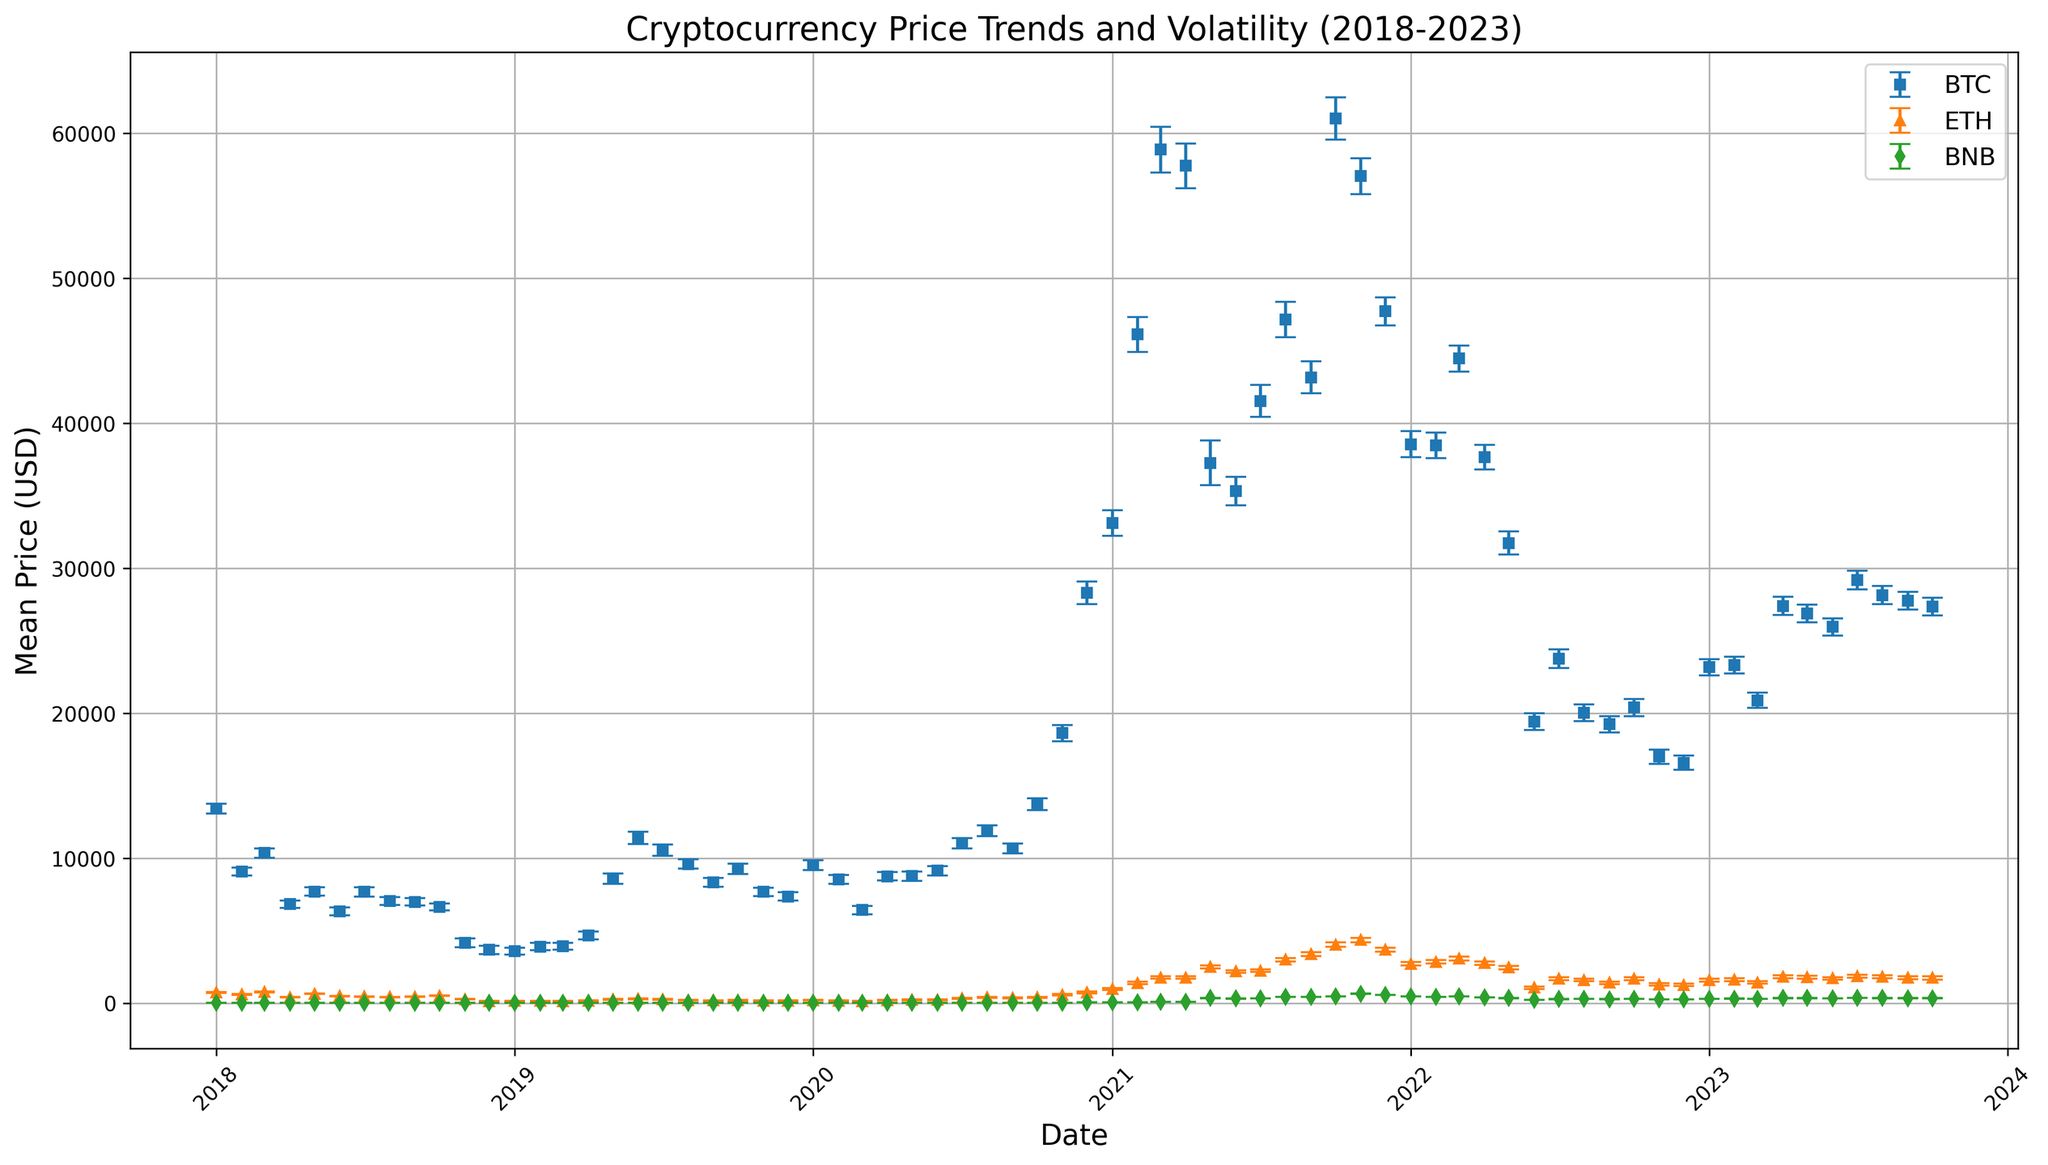What is the range of BTC mean prices during the given period? To determine the range of BTC mean prices, subtract the lowest mean price from the highest mean price. From the chart, the lowest BTC mean price is around December 2018 at approximately $3669.97, and the highest mean price is around March 2021 at approximately $58874.45. Hence, the range is $58874.45 - $3669.97.
Answer: $55204.48 Which cryptocurrency showed the highest price volatility in May 2021? Price volatility can be inferred from the standard deviation. In May 2021, compare the error bars (std deviation) of BTC, ETH, and BNB. BTC's error bar looks around 1542.12, ETH's around 96.78, and BNB's around 6.12. BTC clearly shows the highest price volatility.
Answer: BTC How did ETH's mean price change from January 2018 to February 2018? We need to compare ETH's mean prices between these two months. In January 2018, the mean price of ETH is approximately $728.45. In February 2018, it's about $598.32. Calculate the change as $728.45 - $598.32.
Answer: Decreased by $130.13 Between July 2020 and December 2020, did any cryptocurrency show a period of decreasing mean prices? Check the mean price trends for BTC, ETH, and BNB between these months. BTC shows an increasing trend during this period, ETH also increases, and BNB shows a slight decrease, especially August 2020 to September 2020.
Answer: Yes, BNB Which month recorded the highest discrepancy between BTC and ETH's mean prices? To answer this, compute the differences between BTC and ETH's mean prices each month. Compare the absolute values of these differences to identify the largest one. From a quick look, March 2021 (BTC ≈ $58874.45, ETH ≈ $1754.23) shows a significant difference.
Answer: March 2021 Consider a period where BTC and ETH's mean prices both drop. Identify one such period and state the percentage drop for BTC. We need to find a period where both BTC and ETH show a mean price decrease. For example, from April 2021 to May 2021, BTC drops from approximately $57748.12 to $37263.56 and ETH from $1757.56 to $2506.23. Calculate BTC's percentage drop as ((57748.12 - 37263.56) / 57748.12) * 100%.
Answer: April 2021 to May 2021, approximately 35.5% Visualize and compare BNB's volatility trend to BTC's over 2021. Have they followed similar volatility patterns? Assess the consistency and height of the error bars for BNB and BTC throughout 2021. BTC shows significant spikes in volatility, especially February and March 2021, while BNB shows comparatively lower and steadier error bars, indicating more consistent volatility.
Answer: No, BNB is more consistent, BTC is more volatile 